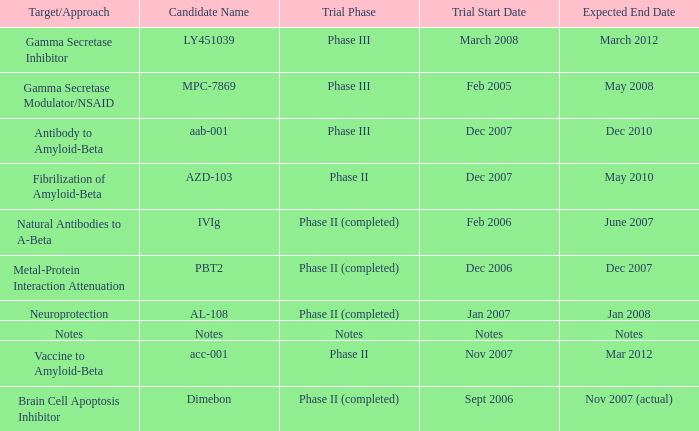What is Trial Start Date, when Candidate Name is Notes? Notes. 